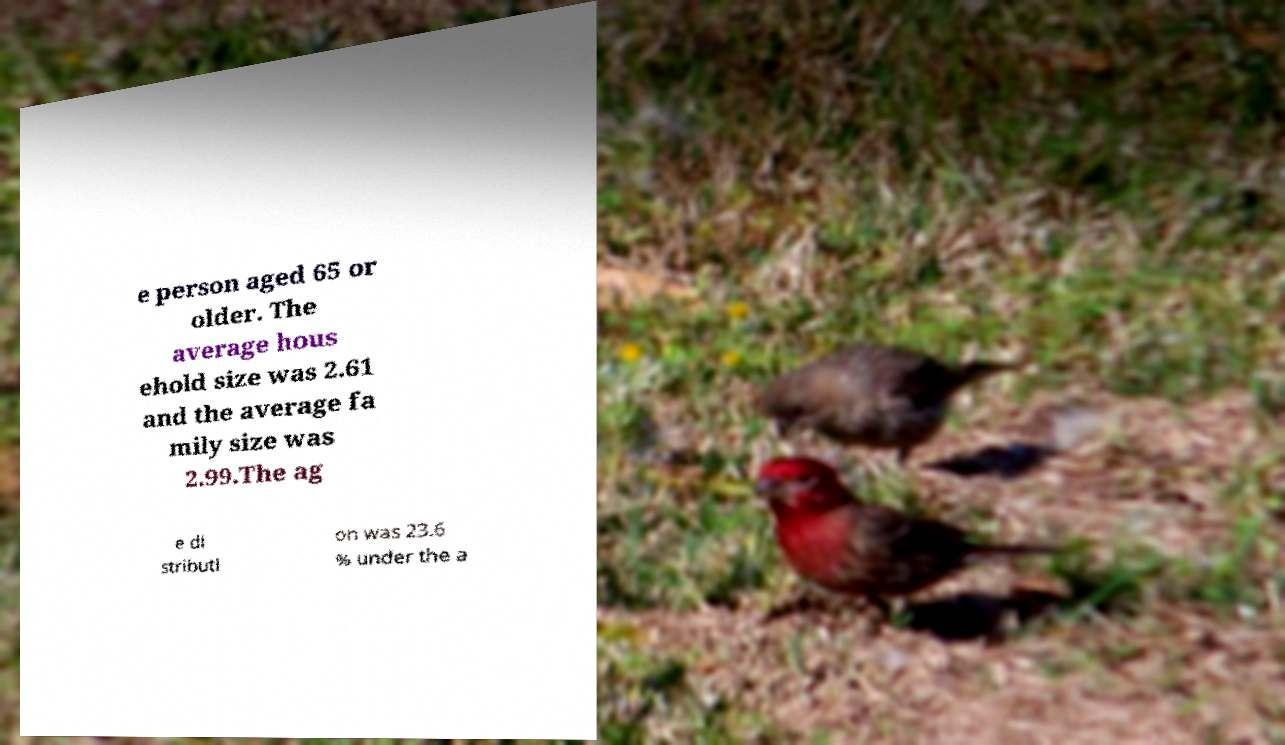Could you assist in decoding the text presented in this image and type it out clearly? e person aged 65 or older. The average hous ehold size was 2.61 and the average fa mily size was 2.99.The ag e di stributi on was 23.6 % under the a 